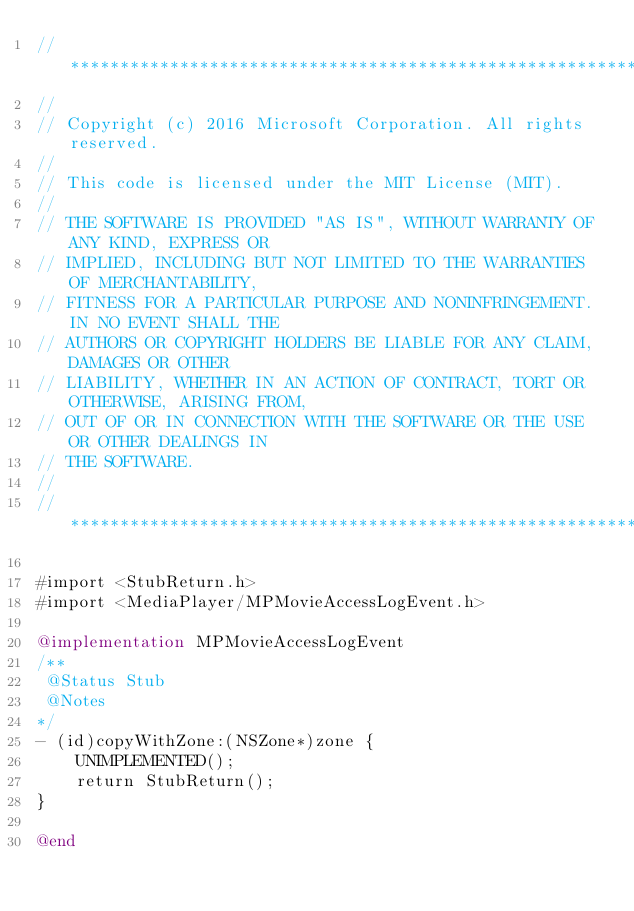<code> <loc_0><loc_0><loc_500><loc_500><_ObjectiveC_>//******************************************************************************
//
// Copyright (c) 2016 Microsoft Corporation. All rights reserved.
//
// This code is licensed under the MIT License (MIT).
//
// THE SOFTWARE IS PROVIDED "AS IS", WITHOUT WARRANTY OF ANY KIND, EXPRESS OR
// IMPLIED, INCLUDING BUT NOT LIMITED TO THE WARRANTIES OF MERCHANTABILITY,
// FITNESS FOR A PARTICULAR PURPOSE AND NONINFRINGEMENT. IN NO EVENT SHALL THE
// AUTHORS OR COPYRIGHT HOLDERS BE LIABLE FOR ANY CLAIM, DAMAGES OR OTHER
// LIABILITY, WHETHER IN AN ACTION OF CONTRACT, TORT OR OTHERWISE, ARISING FROM,
// OUT OF OR IN CONNECTION WITH THE SOFTWARE OR THE USE OR OTHER DEALINGS IN
// THE SOFTWARE.
//
//******************************************************************************

#import <StubReturn.h>
#import <MediaPlayer/MPMovieAccessLogEvent.h>

@implementation MPMovieAccessLogEvent
/**
 @Status Stub
 @Notes
*/
- (id)copyWithZone:(NSZone*)zone {
    UNIMPLEMENTED();
    return StubReturn();
}

@end
</code> 